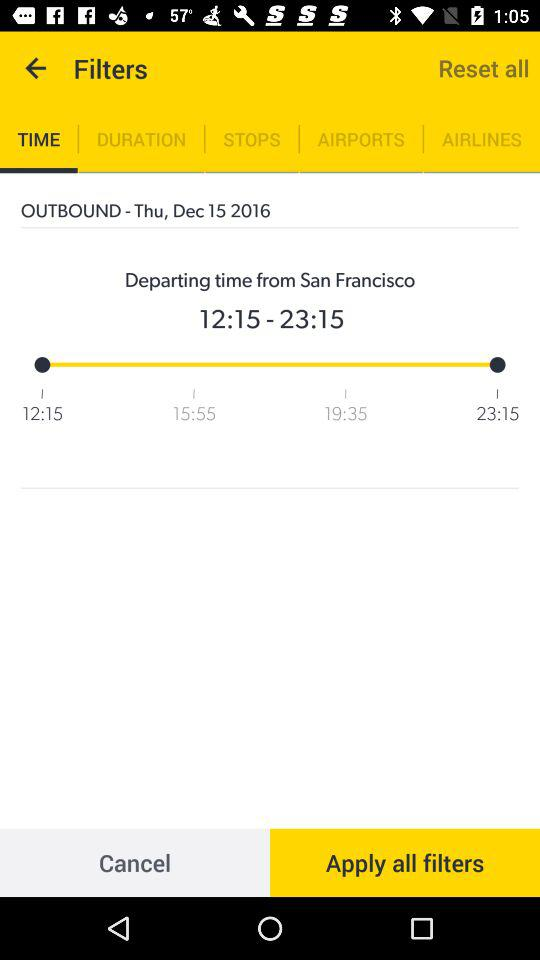How many hours are between the earliest and latest departure times?
Answer the question using a single word or phrase. 11 